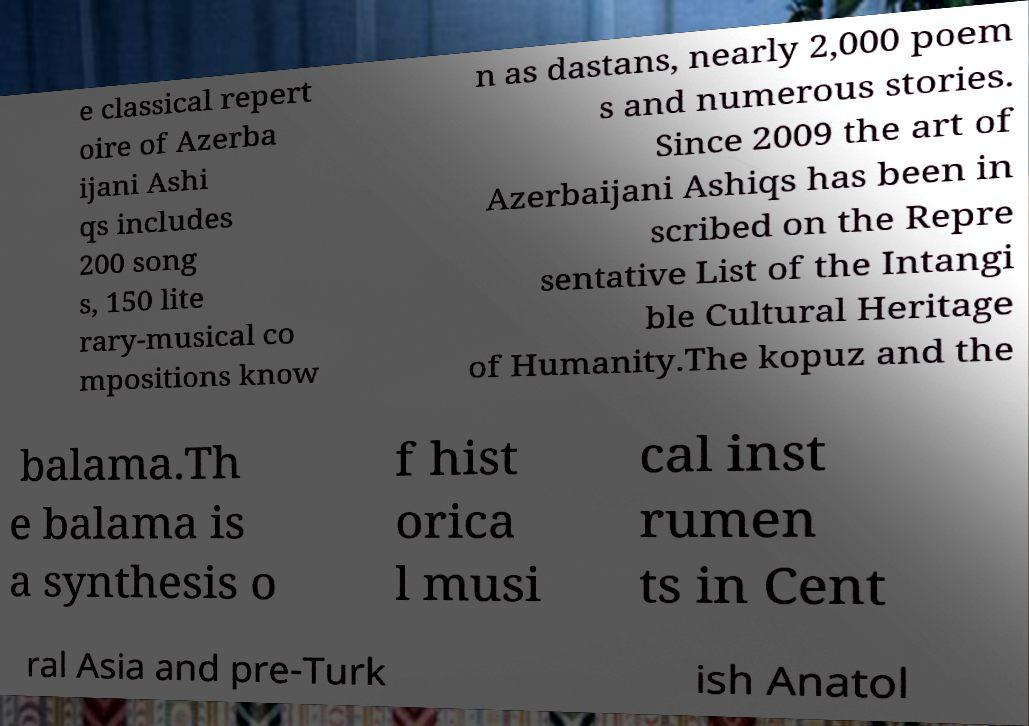Can you read and provide the text displayed in the image?This photo seems to have some interesting text. Can you extract and type it out for me? e classical repert oire of Azerba ijani Ashi qs includes 200 song s, 150 lite rary-musical co mpositions know n as dastans, nearly 2,000 poem s and numerous stories. Since 2009 the art of Azerbaijani Ashiqs has been in scribed on the Repre sentative List of the Intangi ble Cultural Heritage of Humanity.The kopuz and the balama.Th e balama is a synthesis o f hist orica l musi cal inst rumen ts in Cent ral Asia and pre-Turk ish Anatol 